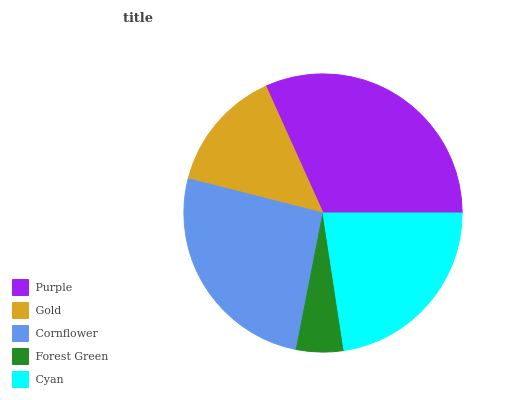Is Forest Green the minimum?
Answer yes or no. Yes. Is Purple the maximum?
Answer yes or no. Yes. Is Gold the minimum?
Answer yes or no. No. Is Gold the maximum?
Answer yes or no. No. Is Purple greater than Gold?
Answer yes or no. Yes. Is Gold less than Purple?
Answer yes or no. Yes. Is Gold greater than Purple?
Answer yes or no. No. Is Purple less than Gold?
Answer yes or no. No. Is Cyan the high median?
Answer yes or no. Yes. Is Cyan the low median?
Answer yes or no. Yes. Is Purple the high median?
Answer yes or no. No. Is Cornflower the low median?
Answer yes or no. No. 